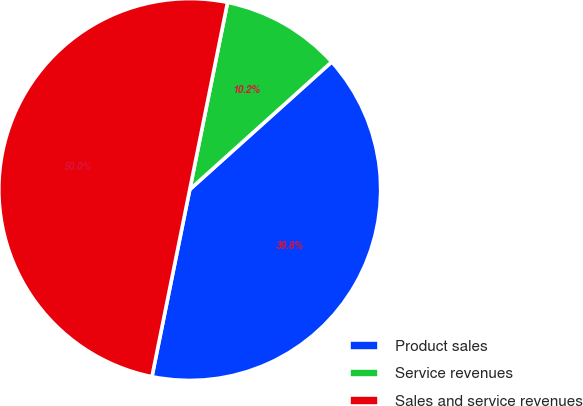Convert chart to OTSL. <chart><loc_0><loc_0><loc_500><loc_500><pie_chart><fcel>Product sales<fcel>Service revenues<fcel>Sales and service revenues<nl><fcel>39.83%<fcel>10.17%<fcel>50.0%<nl></chart> 